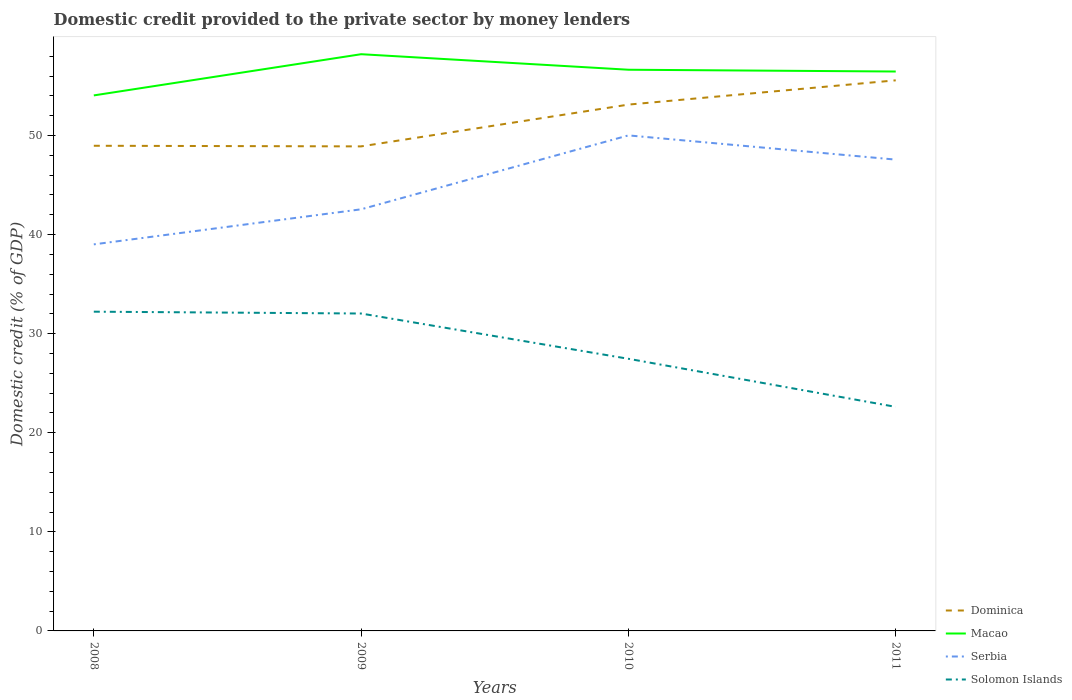Across all years, what is the maximum domestic credit provided to the private sector by money lenders in Dominica?
Your answer should be compact. 48.9. What is the total domestic credit provided to the private sector by money lenders in Solomon Islands in the graph?
Keep it short and to the point. 4.85. What is the difference between the highest and the second highest domestic credit provided to the private sector by money lenders in Dominica?
Provide a succinct answer. 6.67. Is the domestic credit provided to the private sector by money lenders in Macao strictly greater than the domestic credit provided to the private sector by money lenders in Serbia over the years?
Your answer should be very brief. No. How many lines are there?
Give a very brief answer. 4. Where does the legend appear in the graph?
Ensure brevity in your answer.  Bottom right. How many legend labels are there?
Ensure brevity in your answer.  4. What is the title of the graph?
Offer a very short reply. Domestic credit provided to the private sector by money lenders. Does "Mexico" appear as one of the legend labels in the graph?
Give a very brief answer. No. What is the label or title of the Y-axis?
Ensure brevity in your answer.  Domestic credit (% of GDP). What is the Domestic credit (% of GDP) of Dominica in 2008?
Provide a succinct answer. 48.96. What is the Domestic credit (% of GDP) of Macao in 2008?
Give a very brief answer. 54.04. What is the Domestic credit (% of GDP) in Serbia in 2008?
Give a very brief answer. 39.01. What is the Domestic credit (% of GDP) of Solomon Islands in 2008?
Your answer should be compact. 32.22. What is the Domestic credit (% of GDP) of Dominica in 2009?
Give a very brief answer. 48.9. What is the Domestic credit (% of GDP) of Macao in 2009?
Provide a succinct answer. 58.2. What is the Domestic credit (% of GDP) of Serbia in 2009?
Provide a succinct answer. 42.55. What is the Domestic credit (% of GDP) in Solomon Islands in 2009?
Make the answer very short. 32.03. What is the Domestic credit (% of GDP) of Dominica in 2010?
Ensure brevity in your answer.  53.12. What is the Domestic credit (% of GDP) of Macao in 2010?
Ensure brevity in your answer.  56.63. What is the Domestic credit (% of GDP) of Serbia in 2010?
Provide a short and direct response. 50.01. What is the Domestic credit (% of GDP) in Solomon Islands in 2010?
Your answer should be compact. 27.46. What is the Domestic credit (% of GDP) in Dominica in 2011?
Keep it short and to the point. 55.56. What is the Domestic credit (% of GDP) in Macao in 2011?
Your answer should be compact. 56.45. What is the Domestic credit (% of GDP) of Serbia in 2011?
Ensure brevity in your answer.  47.56. What is the Domestic credit (% of GDP) in Solomon Islands in 2011?
Ensure brevity in your answer.  22.61. Across all years, what is the maximum Domestic credit (% of GDP) of Dominica?
Offer a very short reply. 55.56. Across all years, what is the maximum Domestic credit (% of GDP) in Macao?
Your answer should be very brief. 58.2. Across all years, what is the maximum Domestic credit (% of GDP) of Serbia?
Your answer should be very brief. 50.01. Across all years, what is the maximum Domestic credit (% of GDP) in Solomon Islands?
Provide a succinct answer. 32.22. Across all years, what is the minimum Domestic credit (% of GDP) of Dominica?
Keep it short and to the point. 48.9. Across all years, what is the minimum Domestic credit (% of GDP) of Macao?
Make the answer very short. 54.04. Across all years, what is the minimum Domestic credit (% of GDP) of Serbia?
Ensure brevity in your answer.  39.01. Across all years, what is the minimum Domestic credit (% of GDP) of Solomon Islands?
Give a very brief answer. 22.61. What is the total Domestic credit (% of GDP) of Dominica in the graph?
Your answer should be compact. 206.54. What is the total Domestic credit (% of GDP) in Macao in the graph?
Offer a terse response. 225.33. What is the total Domestic credit (% of GDP) of Serbia in the graph?
Your answer should be very brief. 179.13. What is the total Domestic credit (% of GDP) in Solomon Islands in the graph?
Your response must be concise. 114.32. What is the difference between the Domestic credit (% of GDP) in Dominica in 2008 and that in 2009?
Ensure brevity in your answer.  0.06. What is the difference between the Domestic credit (% of GDP) of Macao in 2008 and that in 2009?
Provide a short and direct response. -4.16. What is the difference between the Domestic credit (% of GDP) in Serbia in 2008 and that in 2009?
Provide a succinct answer. -3.54. What is the difference between the Domestic credit (% of GDP) in Solomon Islands in 2008 and that in 2009?
Your answer should be compact. 0.19. What is the difference between the Domestic credit (% of GDP) of Dominica in 2008 and that in 2010?
Make the answer very short. -4.15. What is the difference between the Domestic credit (% of GDP) in Macao in 2008 and that in 2010?
Keep it short and to the point. -2.59. What is the difference between the Domestic credit (% of GDP) of Serbia in 2008 and that in 2010?
Ensure brevity in your answer.  -11. What is the difference between the Domestic credit (% of GDP) in Solomon Islands in 2008 and that in 2010?
Offer a very short reply. 4.75. What is the difference between the Domestic credit (% of GDP) in Dominica in 2008 and that in 2011?
Keep it short and to the point. -6.6. What is the difference between the Domestic credit (% of GDP) of Macao in 2008 and that in 2011?
Provide a succinct answer. -2.41. What is the difference between the Domestic credit (% of GDP) of Serbia in 2008 and that in 2011?
Make the answer very short. -8.55. What is the difference between the Domestic credit (% of GDP) of Solomon Islands in 2008 and that in 2011?
Provide a short and direct response. 9.61. What is the difference between the Domestic credit (% of GDP) in Dominica in 2009 and that in 2010?
Ensure brevity in your answer.  -4.22. What is the difference between the Domestic credit (% of GDP) in Macao in 2009 and that in 2010?
Ensure brevity in your answer.  1.57. What is the difference between the Domestic credit (% of GDP) in Serbia in 2009 and that in 2010?
Offer a terse response. -7.46. What is the difference between the Domestic credit (% of GDP) of Solomon Islands in 2009 and that in 2010?
Ensure brevity in your answer.  4.57. What is the difference between the Domestic credit (% of GDP) in Dominica in 2009 and that in 2011?
Make the answer very short. -6.67. What is the difference between the Domestic credit (% of GDP) of Macao in 2009 and that in 2011?
Your answer should be compact. 1.75. What is the difference between the Domestic credit (% of GDP) in Serbia in 2009 and that in 2011?
Offer a terse response. -5.01. What is the difference between the Domestic credit (% of GDP) of Solomon Islands in 2009 and that in 2011?
Your response must be concise. 9.42. What is the difference between the Domestic credit (% of GDP) in Dominica in 2010 and that in 2011?
Offer a terse response. -2.45. What is the difference between the Domestic credit (% of GDP) of Macao in 2010 and that in 2011?
Your response must be concise. 0.18. What is the difference between the Domestic credit (% of GDP) in Serbia in 2010 and that in 2011?
Offer a very short reply. 2.44. What is the difference between the Domestic credit (% of GDP) of Solomon Islands in 2010 and that in 2011?
Your answer should be compact. 4.85. What is the difference between the Domestic credit (% of GDP) of Dominica in 2008 and the Domestic credit (% of GDP) of Macao in 2009?
Your response must be concise. -9.24. What is the difference between the Domestic credit (% of GDP) of Dominica in 2008 and the Domestic credit (% of GDP) of Serbia in 2009?
Keep it short and to the point. 6.41. What is the difference between the Domestic credit (% of GDP) of Dominica in 2008 and the Domestic credit (% of GDP) of Solomon Islands in 2009?
Provide a succinct answer. 16.93. What is the difference between the Domestic credit (% of GDP) in Macao in 2008 and the Domestic credit (% of GDP) in Serbia in 2009?
Offer a very short reply. 11.49. What is the difference between the Domestic credit (% of GDP) in Macao in 2008 and the Domestic credit (% of GDP) in Solomon Islands in 2009?
Ensure brevity in your answer.  22.01. What is the difference between the Domestic credit (% of GDP) in Serbia in 2008 and the Domestic credit (% of GDP) in Solomon Islands in 2009?
Give a very brief answer. 6.98. What is the difference between the Domestic credit (% of GDP) of Dominica in 2008 and the Domestic credit (% of GDP) of Macao in 2010?
Make the answer very short. -7.67. What is the difference between the Domestic credit (% of GDP) of Dominica in 2008 and the Domestic credit (% of GDP) of Serbia in 2010?
Your response must be concise. -1.05. What is the difference between the Domestic credit (% of GDP) of Dominica in 2008 and the Domestic credit (% of GDP) of Solomon Islands in 2010?
Provide a succinct answer. 21.5. What is the difference between the Domestic credit (% of GDP) in Macao in 2008 and the Domestic credit (% of GDP) in Serbia in 2010?
Give a very brief answer. 4.04. What is the difference between the Domestic credit (% of GDP) of Macao in 2008 and the Domestic credit (% of GDP) of Solomon Islands in 2010?
Ensure brevity in your answer.  26.58. What is the difference between the Domestic credit (% of GDP) in Serbia in 2008 and the Domestic credit (% of GDP) in Solomon Islands in 2010?
Your answer should be compact. 11.55. What is the difference between the Domestic credit (% of GDP) of Dominica in 2008 and the Domestic credit (% of GDP) of Macao in 2011?
Offer a terse response. -7.49. What is the difference between the Domestic credit (% of GDP) in Dominica in 2008 and the Domestic credit (% of GDP) in Serbia in 2011?
Offer a terse response. 1.4. What is the difference between the Domestic credit (% of GDP) in Dominica in 2008 and the Domestic credit (% of GDP) in Solomon Islands in 2011?
Offer a terse response. 26.35. What is the difference between the Domestic credit (% of GDP) in Macao in 2008 and the Domestic credit (% of GDP) in Serbia in 2011?
Your answer should be very brief. 6.48. What is the difference between the Domestic credit (% of GDP) in Macao in 2008 and the Domestic credit (% of GDP) in Solomon Islands in 2011?
Give a very brief answer. 31.43. What is the difference between the Domestic credit (% of GDP) of Serbia in 2008 and the Domestic credit (% of GDP) of Solomon Islands in 2011?
Offer a terse response. 16.4. What is the difference between the Domestic credit (% of GDP) of Dominica in 2009 and the Domestic credit (% of GDP) of Macao in 2010?
Offer a very short reply. -7.74. What is the difference between the Domestic credit (% of GDP) in Dominica in 2009 and the Domestic credit (% of GDP) in Serbia in 2010?
Offer a terse response. -1.11. What is the difference between the Domestic credit (% of GDP) of Dominica in 2009 and the Domestic credit (% of GDP) of Solomon Islands in 2010?
Your answer should be compact. 21.43. What is the difference between the Domestic credit (% of GDP) of Macao in 2009 and the Domestic credit (% of GDP) of Serbia in 2010?
Give a very brief answer. 8.19. What is the difference between the Domestic credit (% of GDP) of Macao in 2009 and the Domestic credit (% of GDP) of Solomon Islands in 2010?
Offer a terse response. 30.74. What is the difference between the Domestic credit (% of GDP) in Serbia in 2009 and the Domestic credit (% of GDP) in Solomon Islands in 2010?
Your response must be concise. 15.09. What is the difference between the Domestic credit (% of GDP) of Dominica in 2009 and the Domestic credit (% of GDP) of Macao in 2011?
Keep it short and to the point. -7.56. What is the difference between the Domestic credit (% of GDP) of Dominica in 2009 and the Domestic credit (% of GDP) of Serbia in 2011?
Your answer should be compact. 1.33. What is the difference between the Domestic credit (% of GDP) in Dominica in 2009 and the Domestic credit (% of GDP) in Solomon Islands in 2011?
Keep it short and to the point. 26.29. What is the difference between the Domestic credit (% of GDP) of Macao in 2009 and the Domestic credit (% of GDP) of Serbia in 2011?
Provide a short and direct response. 10.64. What is the difference between the Domestic credit (% of GDP) of Macao in 2009 and the Domestic credit (% of GDP) of Solomon Islands in 2011?
Provide a succinct answer. 35.59. What is the difference between the Domestic credit (% of GDP) of Serbia in 2009 and the Domestic credit (% of GDP) of Solomon Islands in 2011?
Ensure brevity in your answer.  19.94. What is the difference between the Domestic credit (% of GDP) in Dominica in 2010 and the Domestic credit (% of GDP) in Macao in 2011?
Offer a very short reply. -3.34. What is the difference between the Domestic credit (% of GDP) of Dominica in 2010 and the Domestic credit (% of GDP) of Serbia in 2011?
Offer a very short reply. 5.55. What is the difference between the Domestic credit (% of GDP) of Dominica in 2010 and the Domestic credit (% of GDP) of Solomon Islands in 2011?
Offer a very short reply. 30.51. What is the difference between the Domestic credit (% of GDP) of Macao in 2010 and the Domestic credit (% of GDP) of Serbia in 2011?
Give a very brief answer. 9.07. What is the difference between the Domestic credit (% of GDP) of Macao in 2010 and the Domestic credit (% of GDP) of Solomon Islands in 2011?
Offer a terse response. 34.02. What is the difference between the Domestic credit (% of GDP) in Serbia in 2010 and the Domestic credit (% of GDP) in Solomon Islands in 2011?
Give a very brief answer. 27.4. What is the average Domestic credit (% of GDP) in Dominica per year?
Offer a very short reply. 51.63. What is the average Domestic credit (% of GDP) of Macao per year?
Your answer should be very brief. 56.33. What is the average Domestic credit (% of GDP) of Serbia per year?
Ensure brevity in your answer.  44.78. What is the average Domestic credit (% of GDP) in Solomon Islands per year?
Provide a short and direct response. 28.58. In the year 2008, what is the difference between the Domestic credit (% of GDP) in Dominica and Domestic credit (% of GDP) in Macao?
Make the answer very short. -5.08. In the year 2008, what is the difference between the Domestic credit (% of GDP) in Dominica and Domestic credit (% of GDP) in Serbia?
Offer a very short reply. 9.95. In the year 2008, what is the difference between the Domestic credit (% of GDP) in Dominica and Domestic credit (% of GDP) in Solomon Islands?
Your answer should be compact. 16.74. In the year 2008, what is the difference between the Domestic credit (% of GDP) in Macao and Domestic credit (% of GDP) in Serbia?
Make the answer very short. 15.03. In the year 2008, what is the difference between the Domestic credit (% of GDP) of Macao and Domestic credit (% of GDP) of Solomon Islands?
Make the answer very short. 21.83. In the year 2008, what is the difference between the Domestic credit (% of GDP) in Serbia and Domestic credit (% of GDP) in Solomon Islands?
Give a very brief answer. 6.79. In the year 2009, what is the difference between the Domestic credit (% of GDP) of Dominica and Domestic credit (% of GDP) of Macao?
Your answer should be very brief. -9.3. In the year 2009, what is the difference between the Domestic credit (% of GDP) in Dominica and Domestic credit (% of GDP) in Serbia?
Your response must be concise. 6.35. In the year 2009, what is the difference between the Domestic credit (% of GDP) of Dominica and Domestic credit (% of GDP) of Solomon Islands?
Make the answer very short. 16.87. In the year 2009, what is the difference between the Domestic credit (% of GDP) in Macao and Domestic credit (% of GDP) in Serbia?
Your answer should be very brief. 15.65. In the year 2009, what is the difference between the Domestic credit (% of GDP) in Macao and Domestic credit (% of GDP) in Solomon Islands?
Offer a terse response. 26.17. In the year 2009, what is the difference between the Domestic credit (% of GDP) of Serbia and Domestic credit (% of GDP) of Solomon Islands?
Keep it short and to the point. 10.52. In the year 2010, what is the difference between the Domestic credit (% of GDP) in Dominica and Domestic credit (% of GDP) in Macao?
Your answer should be very brief. -3.52. In the year 2010, what is the difference between the Domestic credit (% of GDP) of Dominica and Domestic credit (% of GDP) of Serbia?
Give a very brief answer. 3.11. In the year 2010, what is the difference between the Domestic credit (% of GDP) of Dominica and Domestic credit (% of GDP) of Solomon Islands?
Provide a succinct answer. 25.65. In the year 2010, what is the difference between the Domestic credit (% of GDP) in Macao and Domestic credit (% of GDP) in Serbia?
Provide a succinct answer. 6.63. In the year 2010, what is the difference between the Domestic credit (% of GDP) in Macao and Domestic credit (% of GDP) in Solomon Islands?
Provide a short and direct response. 29.17. In the year 2010, what is the difference between the Domestic credit (% of GDP) in Serbia and Domestic credit (% of GDP) in Solomon Islands?
Ensure brevity in your answer.  22.54. In the year 2011, what is the difference between the Domestic credit (% of GDP) in Dominica and Domestic credit (% of GDP) in Macao?
Offer a terse response. -0.89. In the year 2011, what is the difference between the Domestic credit (% of GDP) of Dominica and Domestic credit (% of GDP) of Serbia?
Provide a short and direct response. 8. In the year 2011, what is the difference between the Domestic credit (% of GDP) in Dominica and Domestic credit (% of GDP) in Solomon Islands?
Your answer should be compact. 32.95. In the year 2011, what is the difference between the Domestic credit (% of GDP) in Macao and Domestic credit (% of GDP) in Serbia?
Keep it short and to the point. 8.89. In the year 2011, what is the difference between the Domestic credit (% of GDP) in Macao and Domestic credit (% of GDP) in Solomon Islands?
Make the answer very short. 33.84. In the year 2011, what is the difference between the Domestic credit (% of GDP) of Serbia and Domestic credit (% of GDP) of Solomon Islands?
Make the answer very short. 24.95. What is the ratio of the Domestic credit (% of GDP) of Macao in 2008 to that in 2009?
Make the answer very short. 0.93. What is the ratio of the Domestic credit (% of GDP) in Serbia in 2008 to that in 2009?
Provide a short and direct response. 0.92. What is the ratio of the Domestic credit (% of GDP) in Solomon Islands in 2008 to that in 2009?
Offer a terse response. 1.01. What is the ratio of the Domestic credit (% of GDP) in Dominica in 2008 to that in 2010?
Your answer should be compact. 0.92. What is the ratio of the Domestic credit (% of GDP) in Macao in 2008 to that in 2010?
Keep it short and to the point. 0.95. What is the ratio of the Domestic credit (% of GDP) in Serbia in 2008 to that in 2010?
Offer a very short reply. 0.78. What is the ratio of the Domestic credit (% of GDP) in Solomon Islands in 2008 to that in 2010?
Give a very brief answer. 1.17. What is the ratio of the Domestic credit (% of GDP) of Dominica in 2008 to that in 2011?
Your answer should be very brief. 0.88. What is the ratio of the Domestic credit (% of GDP) of Macao in 2008 to that in 2011?
Your answer should be compact. 0.96. What is the ratio of the Domestic credit (% of GDP) in Serbia in 2008 to that in 2011?
Offer a very short reply. 0.82. What is the ratio of the Domestic credit (% of GDP) of Solomon Islands in 2008 to that in 2011?
Provide a succinct answer. 1.42. What is the ratio of the Domestic credit (% of GDP) of Dominica in 2009 to that in 2010?
Offer a terse response. 0.92. What is the ratio of the Domestic credit (% of GDP) of Macao in 2009 to that in 2010?
Your answer should be very brief. 1.03. What is the ratio of the Domestic credit (% of GDP) in Serbia in 2009 to that in 2010?
Your answer should be compact. 0.85. What is the ratio of the Domestic credit (% of GDP) of Solomon Islands in 2009 to that in 2010?
Offer a very short reply. 1.17. What is the ratio of the Domestic credit (% of GDP) of Dominica in 2009 to that in 2011?
Offer a very short reply. 0.88. What is the ratio of the Domestic credit (% of GDP) of Macao in 2009 to that in 2011?
Make the answer very short. 1.03. What is the ratio of the Domestic credit (% of GDP) of Serbia in 2009 to that in 2011?
Give a very brief answer. 0.89. What is the ratio of the Domestic credit (% of GDP) of Solomon Islands in 2009 to that in 2011?
Provide a succinct answer. 1.42. What is the ratio of the Domestic credit (% of GDP) in Dominica in 2010 to that in 2011?
Your response must be concise. 0.96. What is the ratio of the Domestic credit (% of GDP) in Serbia in 2010 to that in 2011?
Provide a short and direct response. 1.05. What is the ratio of the Domestic credit (% of GDP) in Solomon Islands in 2010 to that in 2011?
Provide a short and direct response. 1.21. What is the difference between the highest and the second highest Domestic credit (% of GDP) of Dominica?
Provide a succinct answer. 2.45. What is the difference between the highest and the second highest Domestic credit (% of GDP) in Macao?
Provide a succinct answer. 1.57. What is the difference between the highest and the second highest Domestic credit (% of GDP) of Serbia?
Make the answer very short. 2.44. What is the difference between the highest and the second highest Domestic credit (% of GDP) in Solomon Islands?
Your answer should be compact. 0.19. What is the difference between the highest and the lowest Domestic credit (% of GDP) of Dominica?
Provide a succinct answer. 6.67. What is the difference between the highest and the lowest Domestic credit (% of GDP) of Macao?
Ensure brevity in your answer.  4.16. What is the difference between the highest and the lowest Domestic credit (% of GDP) in Serbia?
Keep it short and to the point. 11. What is the difference between the highest and the lowest Domestic credit (% of GDP) of Solomon Islands?
Ensure brevity in your answer.  9.61. 